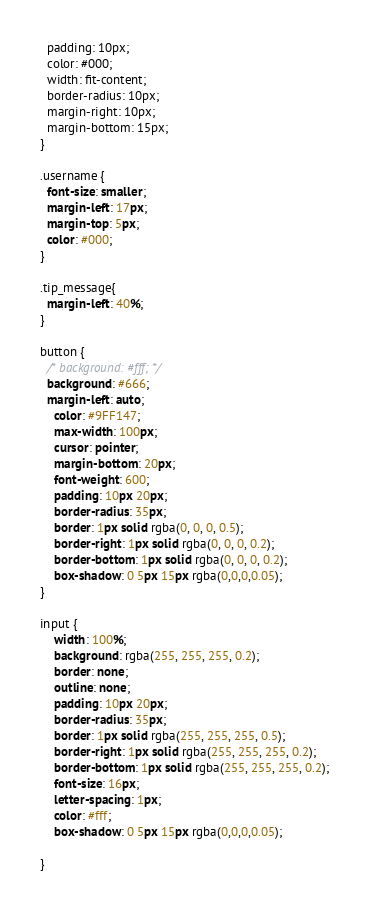<code> <loc_0><loc_0><loc_500><loc_500><_CSS_>  padding: 10px;
  color: #000;
  width: fit-content;
  border-radius: 10px;
  margin-right: 10px;
  margin-bottom: 15px;
}

.username {
  font-size: smaller;
  margin-left: 17px;
  margin-top: 5px;
  color: #000;
}

.tip_message{
  margin-left: 40%;
}

button {
  /* background: #fff; */
  background: #666;
  margin-left: auto;
    color: #9FF147;
    max-width: 100px;
    cursor: pointer;
    margin-bottom: 20px;
    font-weight: 600;
    padding: 10px 20px;
    border-radius: 35px;
    border: 1px solid rgba(0, 0, 0, 0.5);
    border-right: 1px solid rgba(0, 0, 0, 0.2);
    border-bottom: 1px solid rgba(0, 0, 0, 0.2);
    box-shadow: 0 5px 15px rgba(0,0,0,0.05);
}

input {
    width: 100%;
    background: rgba(255, 255, 255, 0.2);
    border: none;
    outline: none;
    padding: 10px 20px;
    border-radius: 35px;
    border: 1px solid rgba(255, 255, 255, 0.5);
    border-right: 1px solid rgba(255, 255, 255, 0.2);
    border-bottom: 1px solid rgba(255, 255, 255, 0.2);
    font-size: 16px;
    letter-spacing: 1px;
    color: #fff;
    box-shadow: 0 5px 15px rgba(0,0,0,0.05);

}</code> 